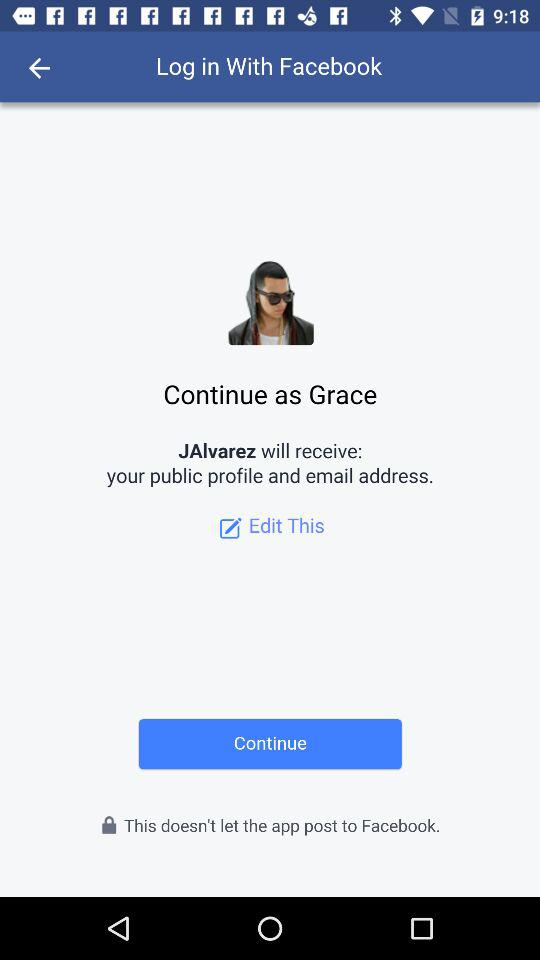What is the user name? The user name is Grace. 